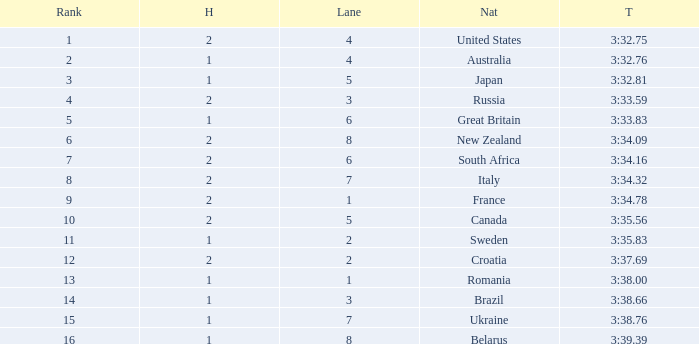Can you tell me the Time that has the Heat of 1, and the Lane of 2? 3:35.83. 